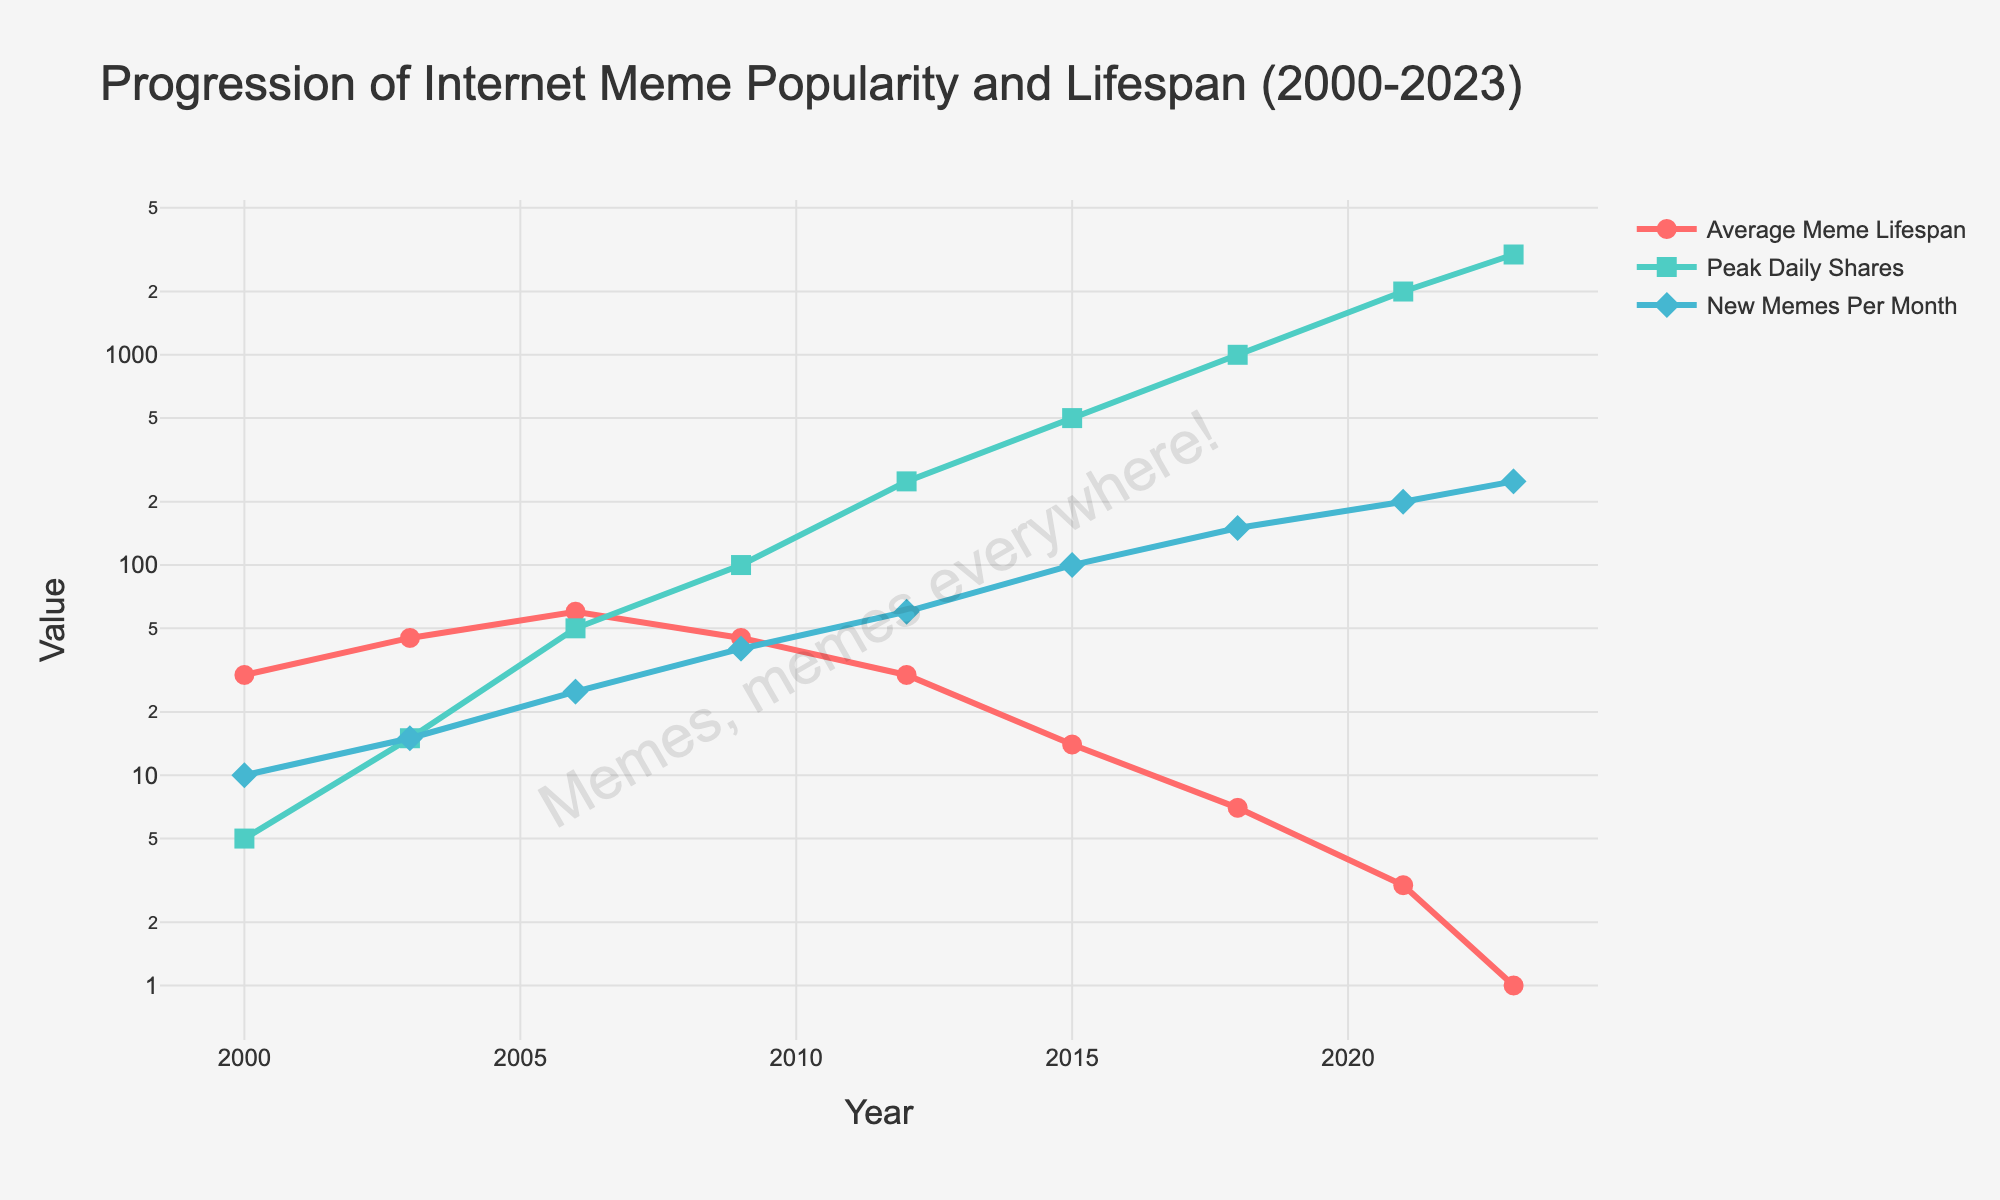What year saw the highest peak daily shares for memes? In the chart, the highest peak daily shares are represented by the highest point on the green line. This highest point is at the year 2023.
Answer: 2023 How did the average meme lifespan change from 2000 to 2023? To determine the change, observe the red line representing the average meme lifespan. In 2000, the lifespan is at its highest around 30 days, and in 2023, it drops to its lowest at 1 day. Thus, there was a decrease.
Answer: Decreased Compare the number of new memes per month in 2012 and 2021. Which year had more new memes? Look for the blue line representing 'New Memes Per Month' at both 2012 and 2021. In 2012, the number is around 60. In 2021, it's 200.
Answer: 2021 What is the trend in the peak daily shares of memes from 2006 to 2023? Observe the green line representing 'Peak Daily Shares (thousands)' between 2006 and 2023. Shares increase from 50 in 2006 to 3000 in 2023, indicating an upward trend.
Answer: Increasing Calculate the difference in peak daily shares between 2009 and 2015. Note the green line's values in 2009 (100) and 2015 (500). Subtract the former from the latter: 500 - 100 = 400.
Answer: 400 How did the number of new memes per month change between 2003 and 2023? Observe the blue line representing 'New Memes Per Month' at 2003 (15) and 2023 (250). There is a significant increase.
Answer: Increased Which year had the highest average meme lifespan? Look at the peaks of the red line. The highest occurs in 2006, where the average lifespan is 60 days.
Answer: 2006 What is the average value of 'New Memes Per Month' for the years 2000, 2003, and 2006? Locate data points on the blue line for the years 2000 (10), 2003 (15), and 2006 (25). Compute average: (10 + 15 + 25) / 3 = 50 / 3 ≈ 16.67.
Answer: 16.67 Compare the slope of the change in peak daily shares between 2009-2012 and 2018-2021. Which period shows a steeper rise? Evaluate the gradient for the green line: 
- 2009 (100) to 2012 (250) 
- 2018 (1000) to 2021 (2000) 
First period: 250 - 100 = 150 over 3 years ⇒ 150/3 = 50 per year 
Second period: 2000 - 1000 = 1000 over 3 years ⇒ 1000/3 ≈ 333.3 per year 
A steeper rise is in the second period.
Answer: 2018-2021 